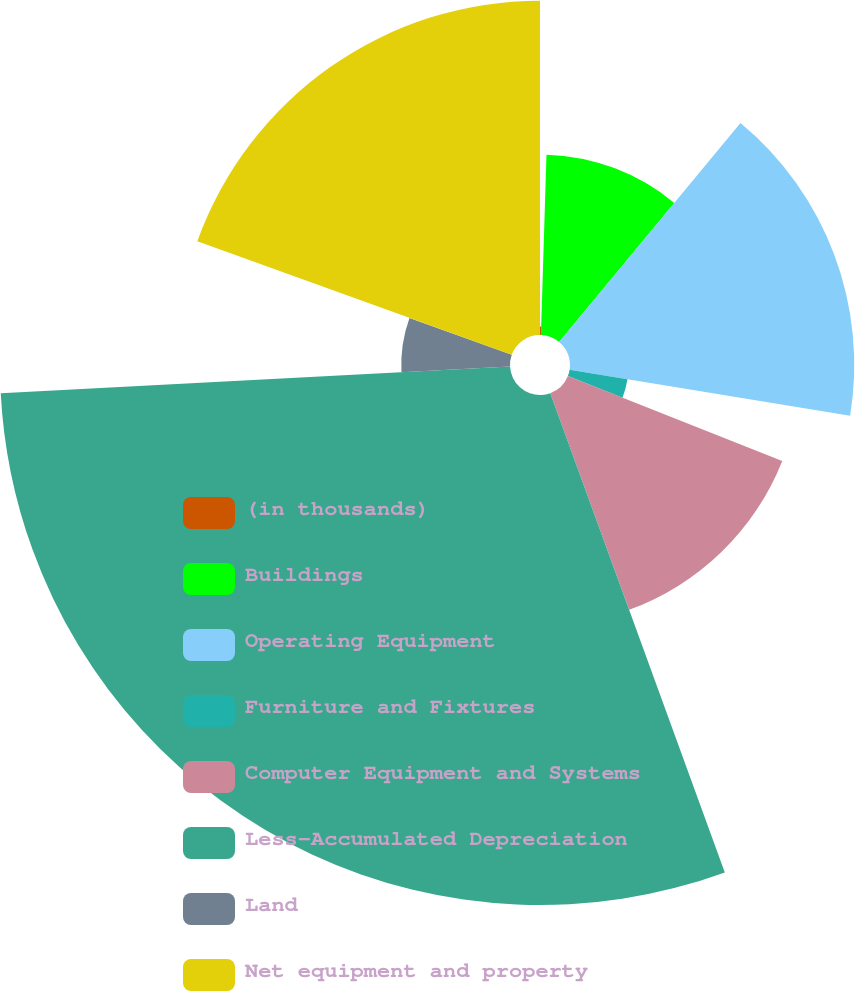<chart> <loc_0><loc_0><loc_500><loc_500><pie_chart><fcel>(in thousands)<fcel>Buildings<fcel>Operating Equipment<fcel>Furniture and Fixtures<fcel>Computer Equipment and Systems<fcel>Less-Accumulated Depreciation<fcel>Land<fcel>Net equipment and property<nl><fcel>0.49%<fcel>10.52%<fcel>16.57%<fcel>3.42%<fcel>13.44%<fcel>29.73%<fcel>6.34%<fcel>19.49%<nl></chart> 